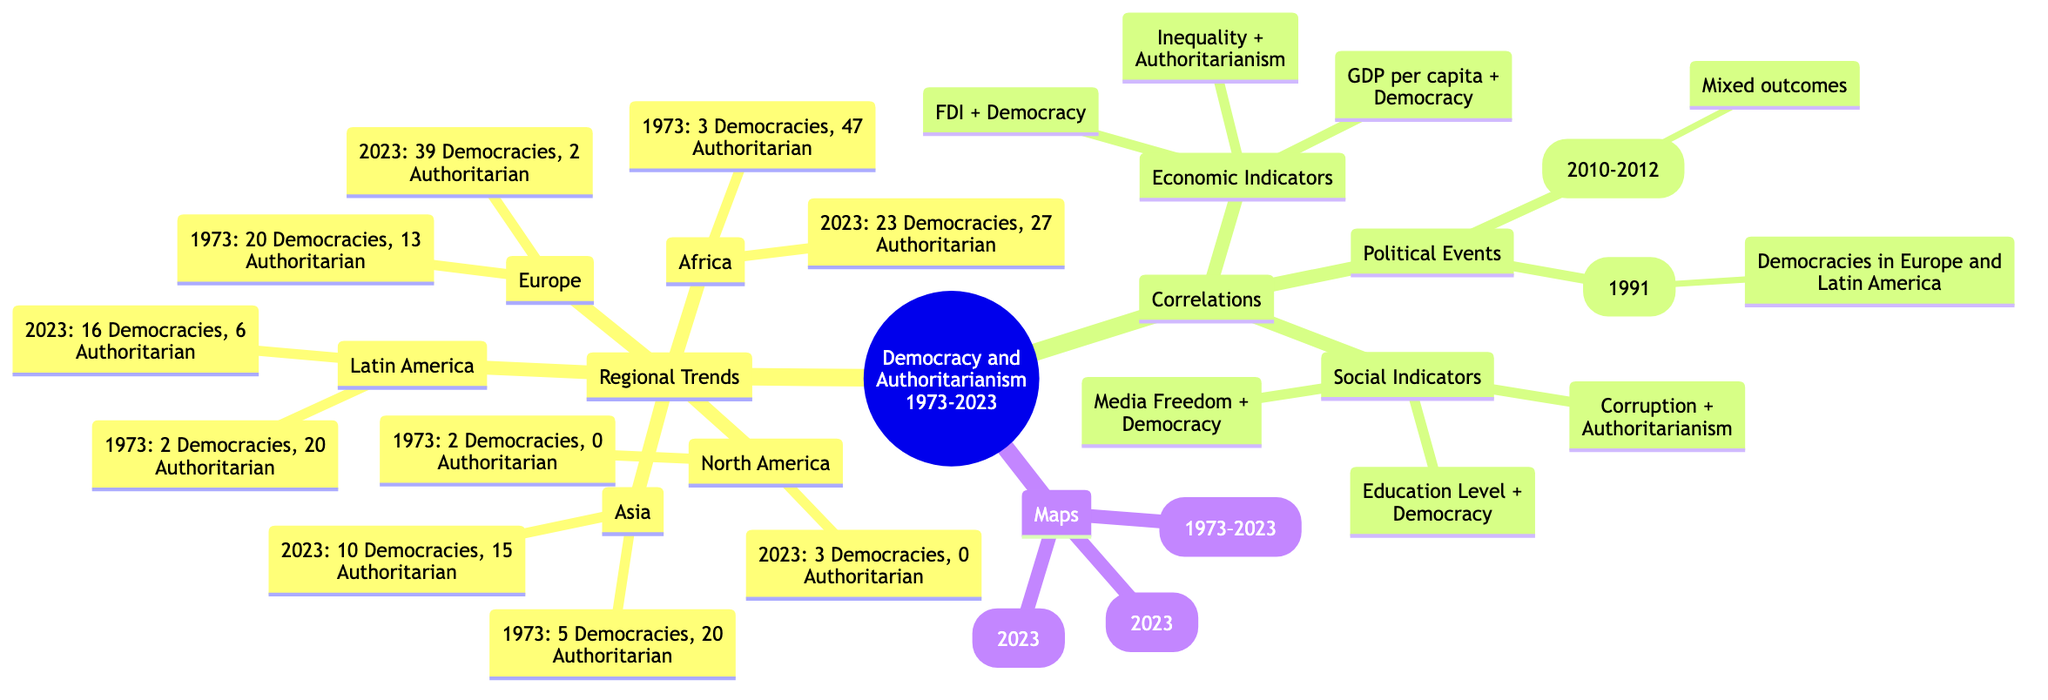What were the number of democracies in Europe in 1973? In the "Europe" section, the diagram states that there were 20 democracies in 1973.
Answer: 20 How many authoritarian regimes were present in Africa in 2023? The "Africa" section indicates that there were 27 authoritarian regimes in 2023.
Answer: 27 What is the correlation between education level and democracy? The diagram states there is a positive correlation between education level and democracy.
Answer: Positive How many democracies existed in Asia in 2023 compared to 1973? In 2023, there were 10 democracies in Asia, an increase from 5 in 1973, indicating a growth of 5 democracies over this period.
Answer: 5 What major political event in 1991 influenced democracies in Europe and Latin America? The diagram notes the end of the Cold War in 1991 led to increased democracies in Europe and Latin America.
Answer: Cold War End How many authoritarian regimes were there in Latin America in 1973? The "Latin America" section shows there were 20 authoritarian regimes in 1973.
Answer: 20 Which region had the most significant increase in democracies between 1973 and 2023? The "Europe" section lists democracies increasing from 20 to 39, making it the region with the most notable increase of 19 democracies.
Answer: Europe What social indicator has a correlation with authoritarianism? The diagram states that corruption correlates with authoritarianism.
Answer: Corruption What was the status of authoritarian regimes in Europe in 2023? The "Europe" section reveals that in 2023, there were only 2 authoritarian regimes remaining.
Answer: 2 